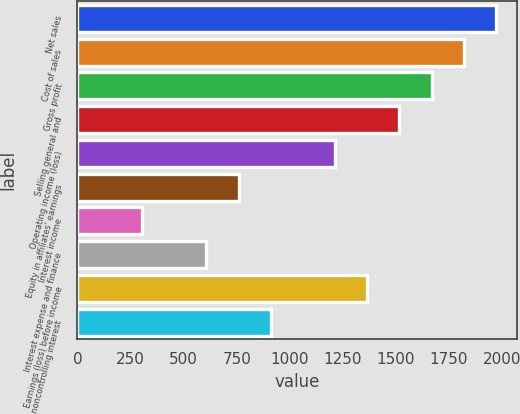Convert chart. <chart><loc_0><loc_0><loc_500><loc_500><bar_chart><fcel>Net sales<fcel>Cost of sales<fcel>Gross profit<fcel>Selling general and<fcel>Operating income (loss)<fcel>Equity in affiliates' earnings<fcel>Interest income<fcel>Interest expense and finance<fcel>Earnings (loss) before income<fcel>noncontrolling interest<nl><fcel>1971.41<fcel>1819.82<fcel>1668.23<fcel>1516.64<fcel>1213.46<fcel>758.69<fcel>303.92<fcel>607.1<fcel>1365.05<fcel>910.28<nl></chart> 